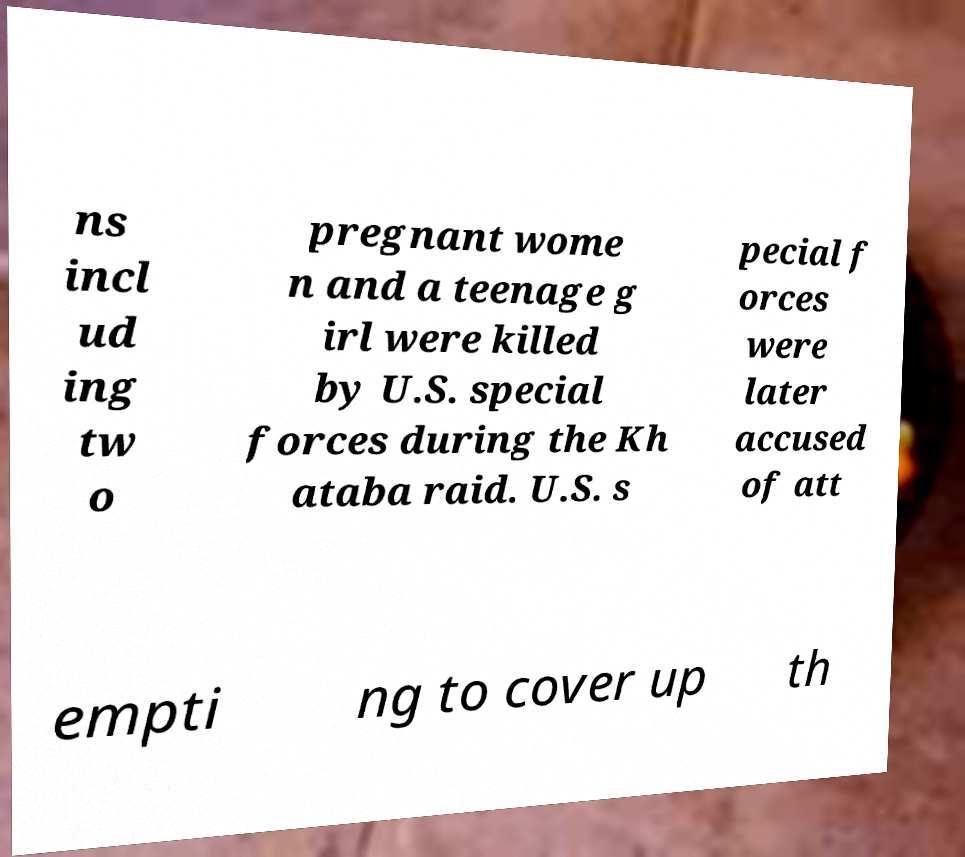For documentation purposes, I need the text within this image transcribed. Could you provide that? ns incl ud ing tw o pregnant wome n and a teenage g irl were killed by U.S. special forces during the Kh ataba raid. U.S. s pecial f orces were later accused of att empti ng to cover up th 